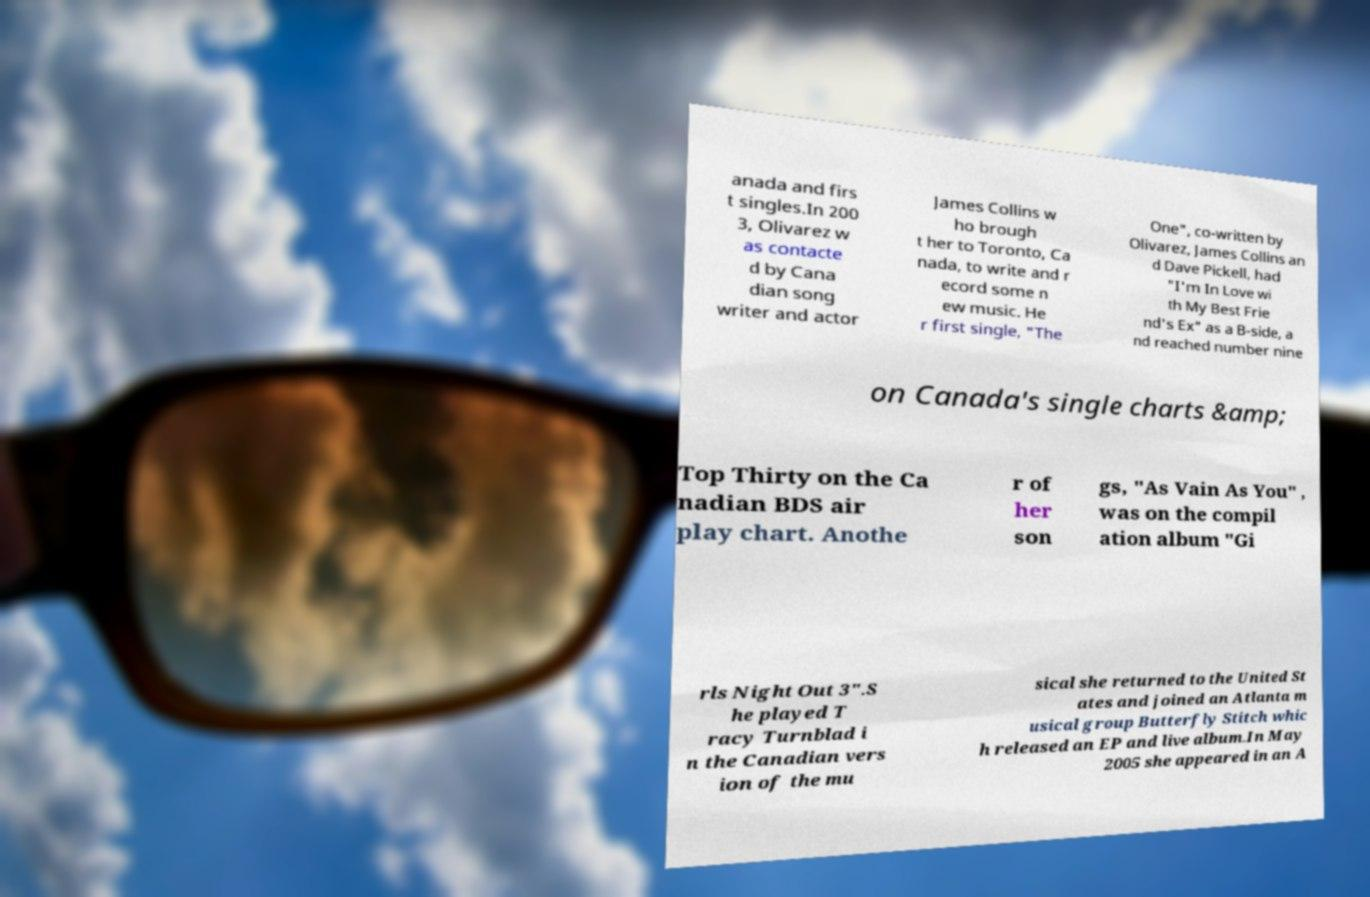Could you assist in decoding the text presented in this image and type it out clearly? anada and firs t singles.In 200 3, Olivarez w as contacte d by Cana dian song writer and actor James Collins w ho brough t her to Toronto, Ca nada, to write and r ecord some n ew music. He r first single, "The One", co-written by Olivarez, James Collins an d Dave Pickell, had "I'm In Love wi th My Best Frie nd's Ex" as a B-side, a nd reached number nine on Canada's single charts &amp; Top Thirty on the Ca nadian BDS air play chart. Anothe r of her son gs, "As Vain As You" , was on the compil ation album "Gi rls Night Out 3".S he played T racy Turnblad i n the Canadian vers ion of the mu sical she returned to the United St ates and joined an Atlanta m usical group Butterfly Stitch whic h released an EP and live album.In May 2005 she appeared in an A 